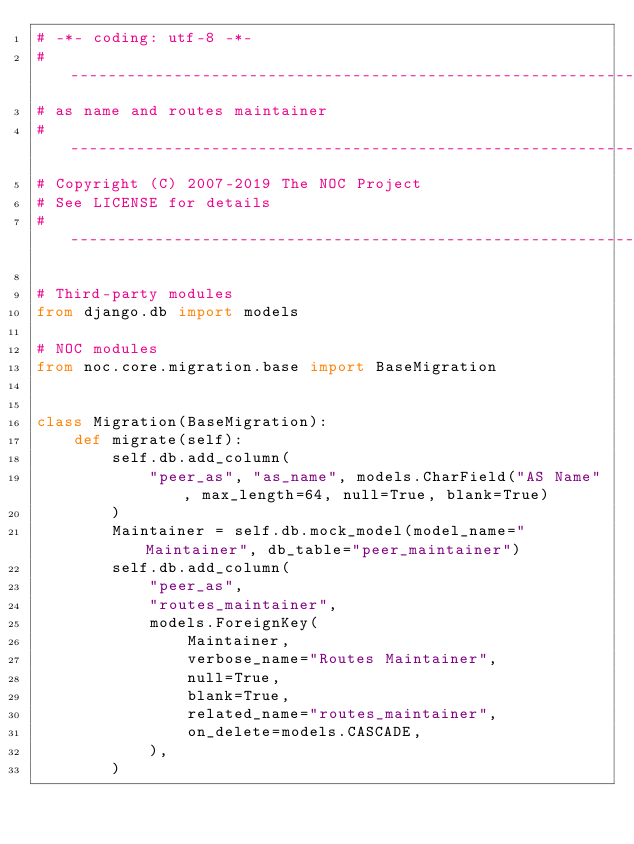Convert code to text. <code><loc_0><loc_0><loc_500><loc_500><_Python_># -*- coding: utf-8 -*-
# ----------------------------------------------------------------------
# as name and routes maintainer
# ----------------------------------------------------------------------
# Copyright (C) 2007-2019 The NOC Project
# See LICENSE for details
# ----------------------------------------------------------------------

# Third-party modules
from django.db import models

# NOC modules
from noc.core.migration.base import BaseMigration


class Migration(BaseMigration):
    def migrate(self):
        self.db.add_column(
            "peer_as", "as_name", models.CharField("AS Name", max_length=64, null=True, blank=True)
        )
        Maintainer = self.db.mock_model(model_name="Maintainer", db_table="peer_maintainer")
        self.db.add_column(
            "peer_as",
            "routes_maintainer",
            models.ForeignKey(
                Maintainer,
                verbose_name="Routes Maintainer",
                null=True,
                blank=True,
                related_name="routes_maintainer",
                on_delete=models.CASCADE,
            ),
        )
</code> 